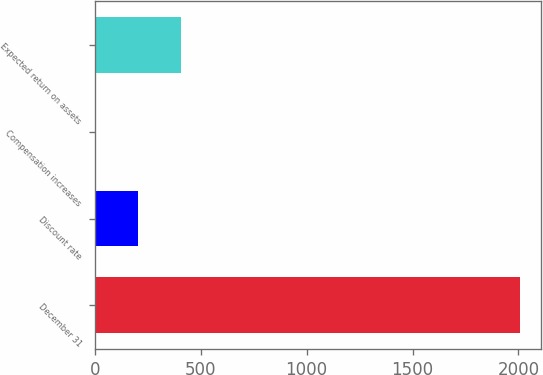<chart> <loc_0><loc_0><loc_500><loc_500><bar_chart><fcel>December 31<fcel>Discount rate<fcel>Compensation increases<fcel>Expected return on assets<nl><fcel>2008<fcel>204.82<fcel>4.47<fcel>405.17<nl></chart> 